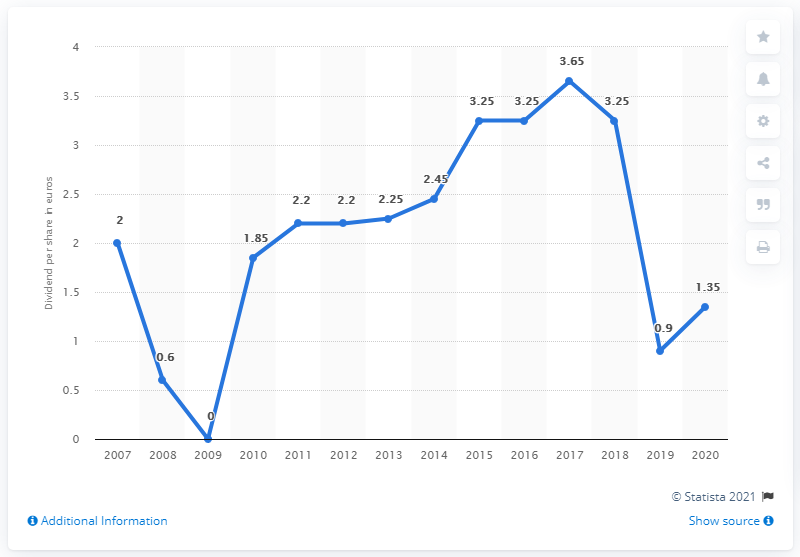Give some essential details in this illustration. The dividend share in 2020 was 0.65, which is different from the dividend share in 2007, which was 0. In the year 2007, Daimler AG's last fiscal year was. The dividend per share in 2015 was 3.25. 